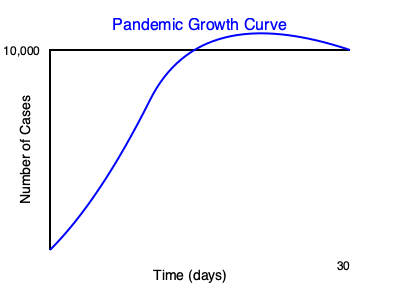Analyze the exponential growth curve of the pandemic spread shown in the graph. If the initial number of cases is 100 and the curve follows the equation $N(t) = N_0 e^{rt}$, where $N_0$ is the initial number of cases, $r$ is the growth rate, and $t$ is time in days, calculate the approximate daily growth rate $r$ given that the number of cases reaches 10,000 after 30 days. To solve this problem, we'll use the exponential growth equation and the given information:

1. Initial number of cases, $N_0 = 100$
2. Final number of cases after 30 days, $N(30) = 10,000$
3. Time period, $t = 30$ days

We'll use the equation $N(t) = N_0 e^{rt}$ and solve for $r$:

1. Substitute the known values into the equation:
   $10,000 = 100 e^{r(30)}$

2. Divide both sides by 100:
   $100 = e^{30r}$

3. Take the natural logarithm of both sides:
   $\ln(100) = 30r$

4. Solve for $r$:
   $r = \frac{\ln(100)}{30}$

5. Calculate the value of $r$:
   $r = \frac{4.6052}{30} \approx 0.1535$

6. Convert to a daily percentage growth rate:
   Daily growth rate $= (e^r - 1) \times 100\% = (e^{0.1535} - 1) \times 100\% \approx 16.59\%$

Therefore, the approximate daily growth rate is 16.59%.
Answer: 16.59% 